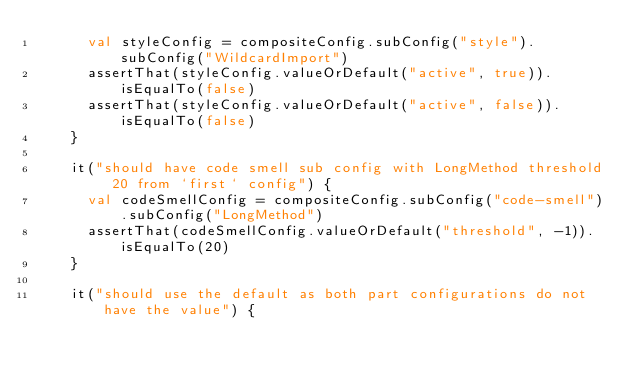<code> <loc_0><loc_0><loc_500><loc_500><_Kotlin_>			val styleConfig = compositeConfig.subConfig("style").subConfig("WildcardImport")
			assertThat(styleConfig.valueOrDefault("active", true)).isEqualTo(false)
			assertThat(styleConfig.valueOrDefault("active", false)).isEqualTo(false)
		}

		it("should have code smell sub config with LongMethod threshold 20 from `first` config") {
			val codeSmellConfig = compositeConfig.subConfig("code-smell").subConfig("LongMethod")
			assertThat(codeSmellConfig.valueOrDefault("threshold", -1)).isEqualTo(20)
		}

		it("should use the default as both part configurations do not have the value") {</code> 